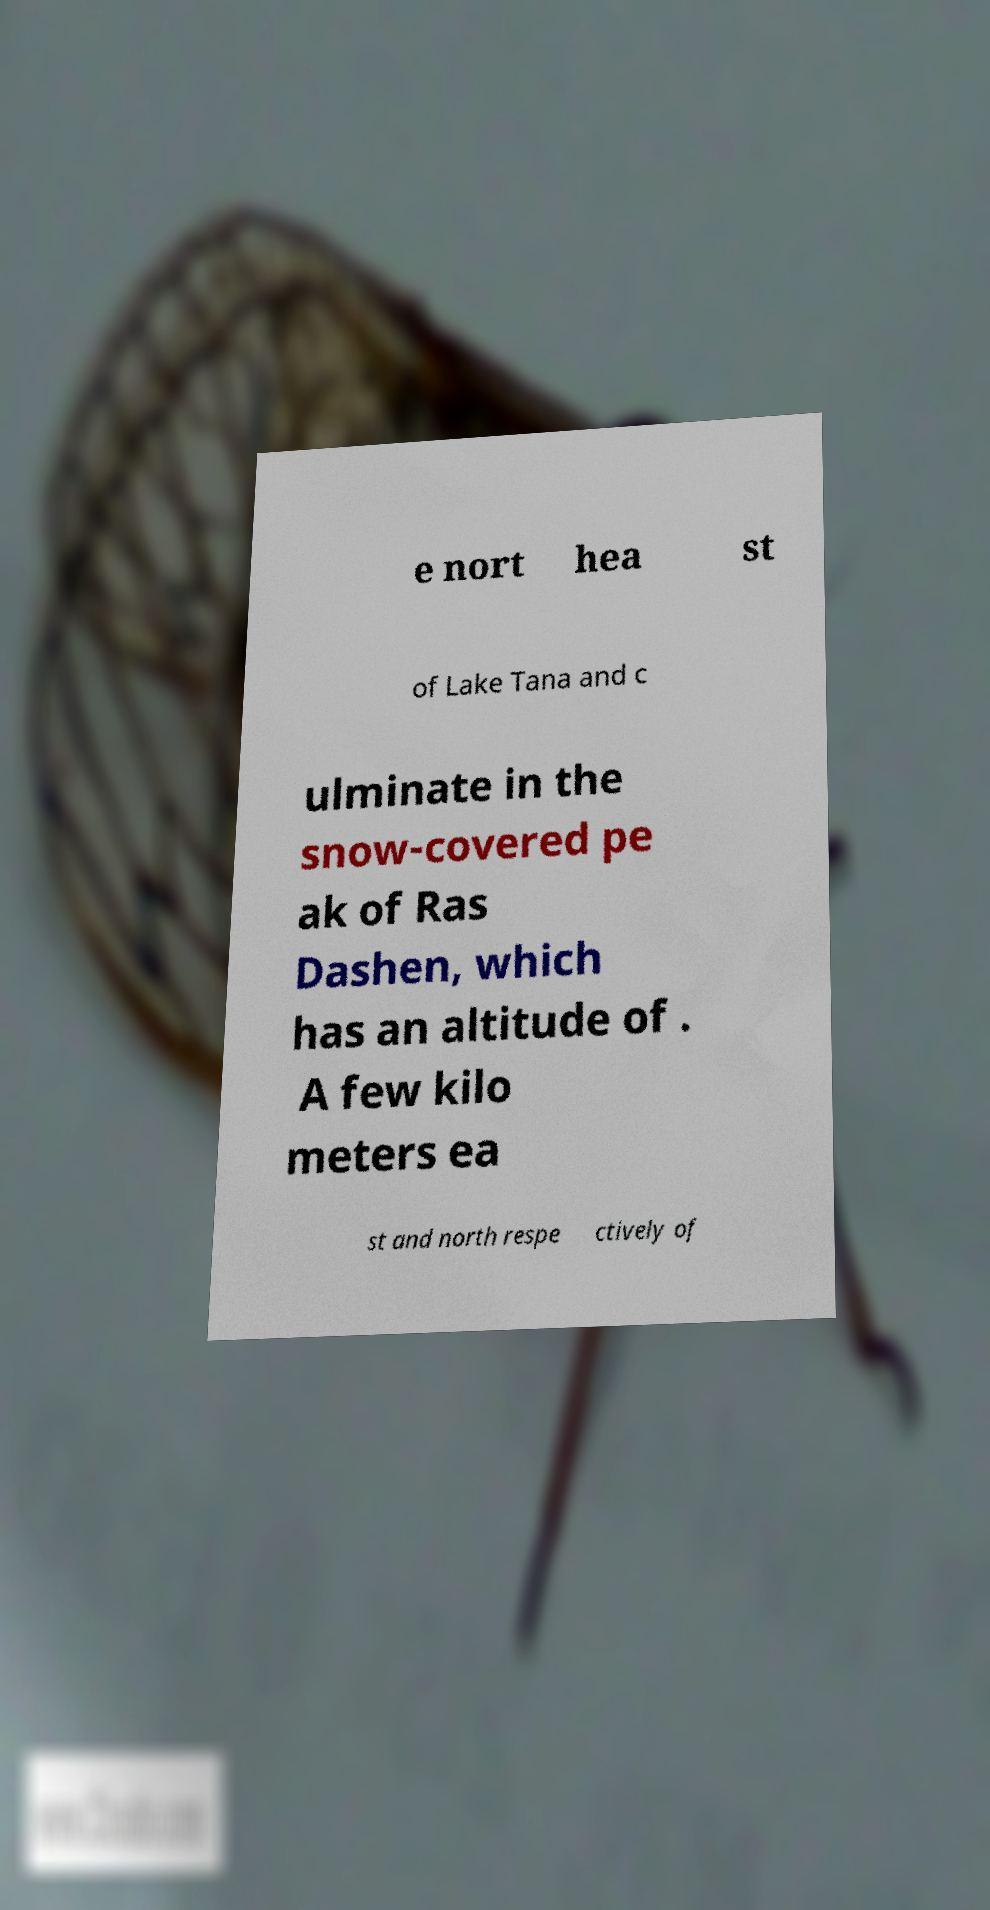For documentation purposes, I need the text within this image transcribed. Could you provide that? e nort hea st of Lake Tana and c ulminate in the snow-covered pe ak of Ras Dashen, which has an altitude of . A few kilo meters ea st and north respe ctively of 